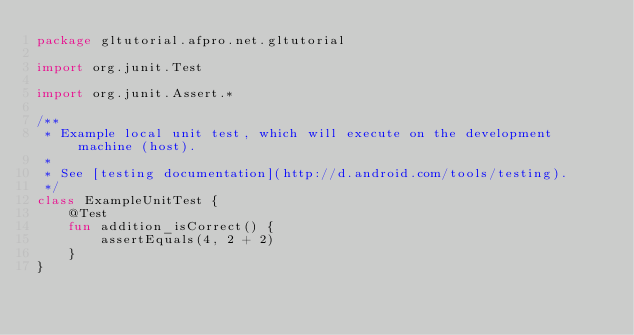<code> <loc_0><loc_0><loc_500><loc_500><_Kotlin_>package gltutorial.afpro.net.gltutorial

import org.junit.Test

import org.junit.Assert.*

/**
 * Example local unit test, which will execute on the development machine (host).
 *
 * See [testing documentation](http://d.android.com/tools/testing).
 */
class ExampleUnitTest {
    @Test
    fun addition_isCorrect() {
        assertEquals(4, 2 + 2)
    }
}
</code> 